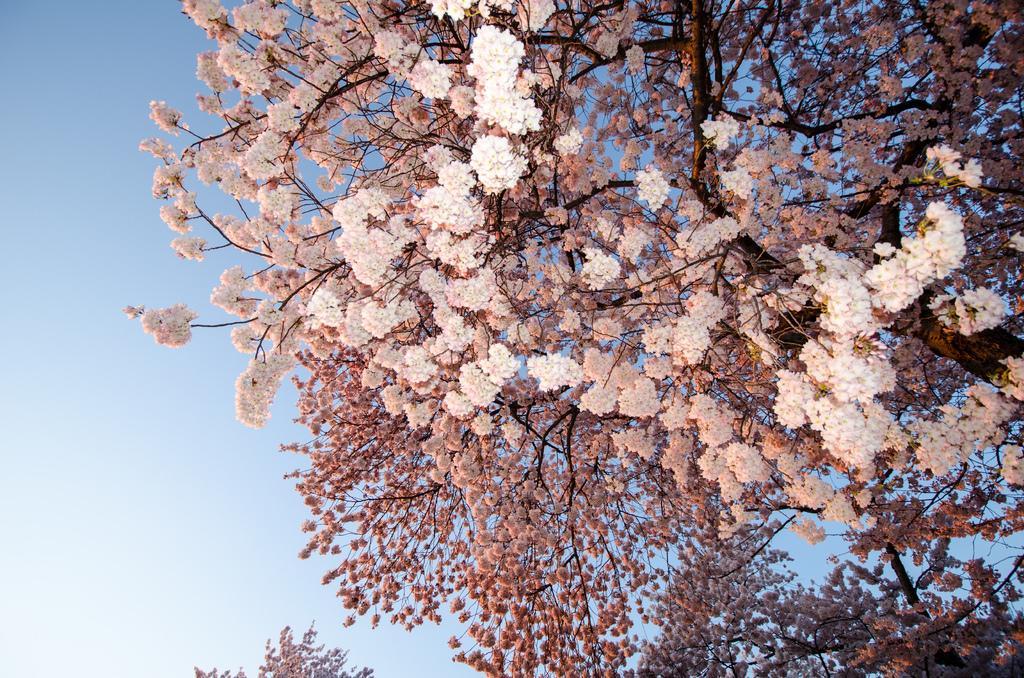Can you describe this image briefly? In this image, we can see trees with some flowers on it. We can also see the sky. 